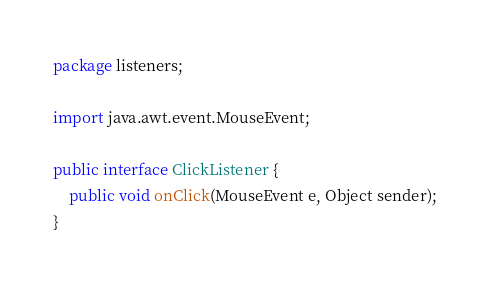Convert code to text. <code><loc_0><loc_0><loc_500><loc_500><_Java_>package listeners;

import java.awt.event.MouseEvent;

public interface ClickListener {	
	public void onClick(MouseEvent e, Object sender);
}
</code> 